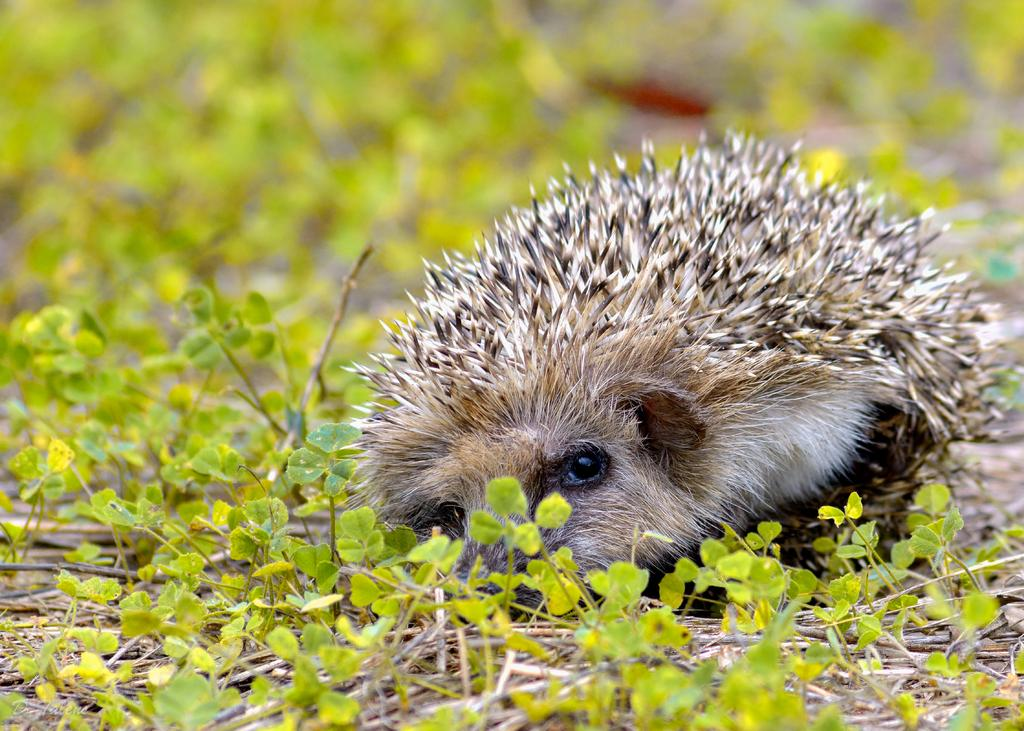What type of animal can be seen on the ground in the image? There is an animal on the ground in the image, but the specific type cannot be determined from the provided facts. What other elements are present in the image besides the animal? There are plants and sticks visible in the image. Can you describe the background of the image? The background of the image is blurred. How many buildings can be seen in the image? There are no buildings present in the image. What type of cloud is visible in the image? There is no cloud visible in the image. 